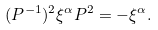Convert formula to latex. <formula><loc_0><loc_0><loc_500><loc_500>( P ^ { - 1 } ) ^ { 2 } \xi ^ { \alpha } P ^ { 2 } = - \xi ^ { \alpha } .</formula> 